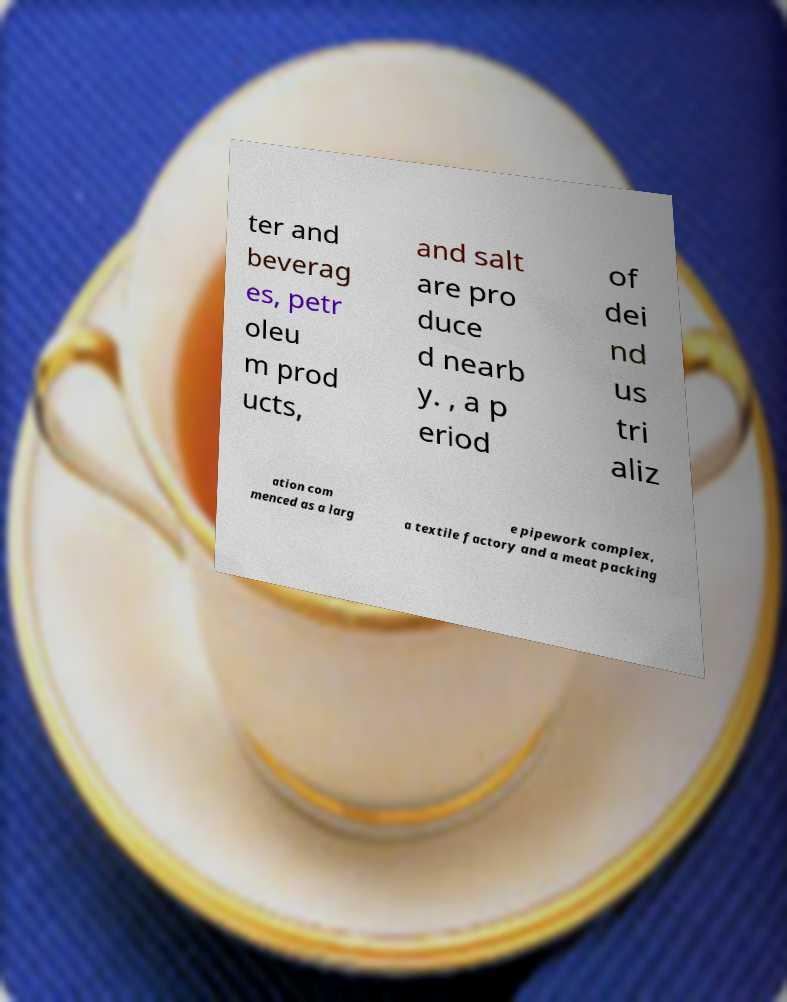Could you extract and type out the text from this image? ter and beverag es, petr oleu m prod ucts, and salt are pro duce d nearb y. , a p eriod of dei nd us tri aliz ation com menced as a larg e pipework complex, a textile factory and a meat packing 